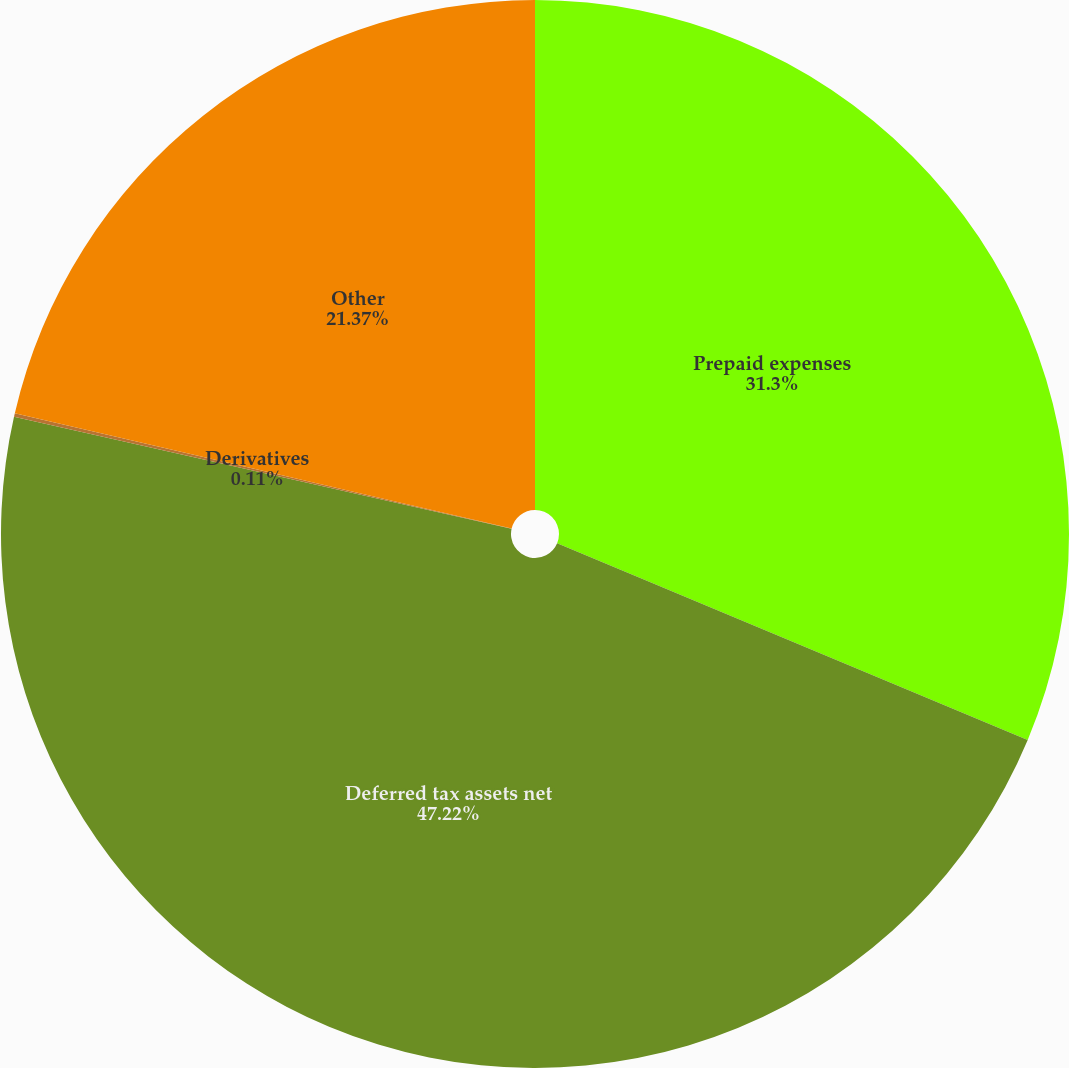<chart> <loc_0><loc_0><loc_500><loc_500><pie_chart><fcel>Prepaid expenses<fcel>Deferred tax assets net<fcel>Derivatives<fcel>Other<nl><fcel>31.3%<fcel>47.22%<fcel>0.11%<fcel>21.37%<nl></chart> 